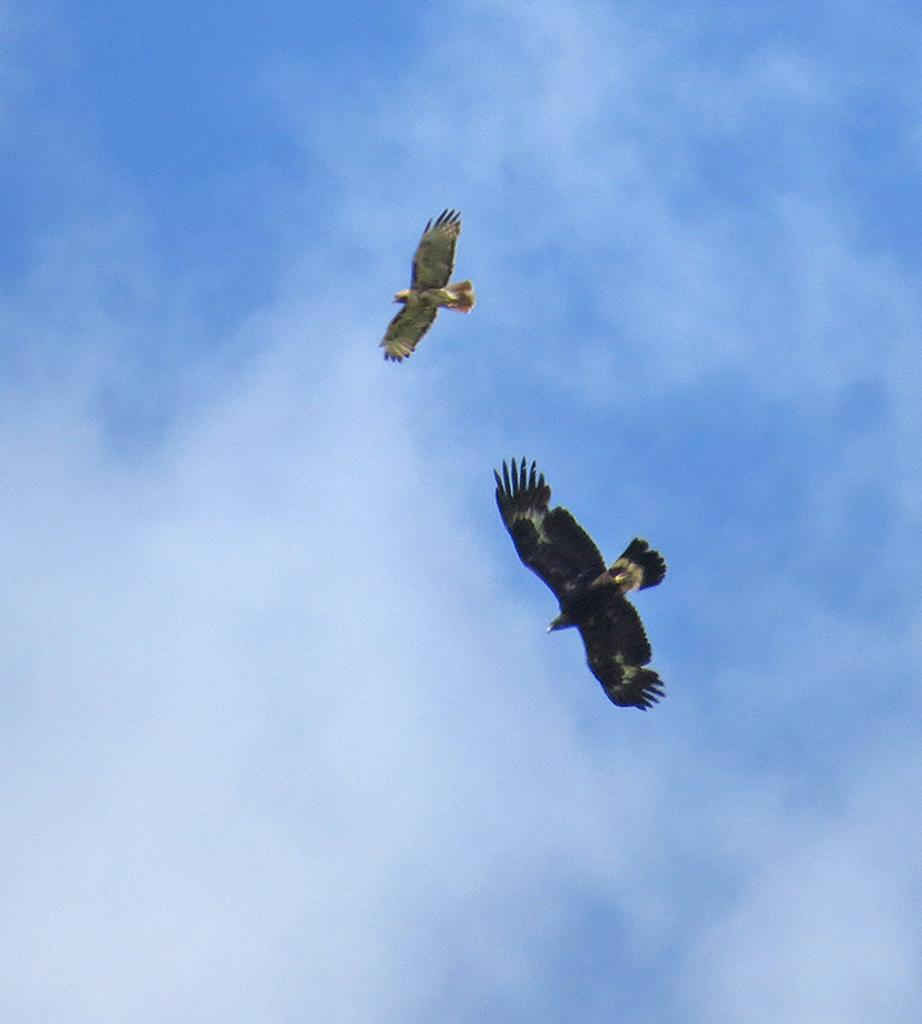What animals are flying in the image? There are two birds flying in the air. What can be seen in the background of the image? The sky is visible in the background. What is present in the sky? Clouds are present in the sky. Who is the owner of the birds in the image? There is no information about the ownership of the birds in the image. 